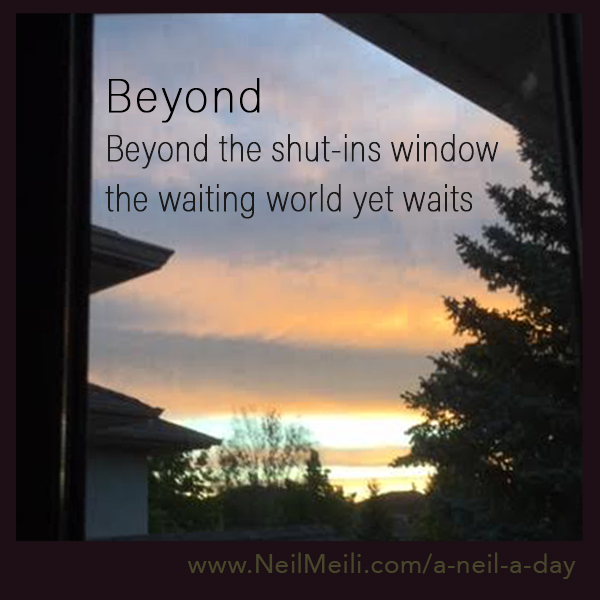Imagine two children looking out of this window, what do they say to each other? "Look at the sky, it looks like a painting!" one child says in awe. "I wonder if we can reach those clouds if we jump high enough," the other replies with a dreamy smile. They both gaze out in silence, sharing an unspoken understanding of the beauty before them. 